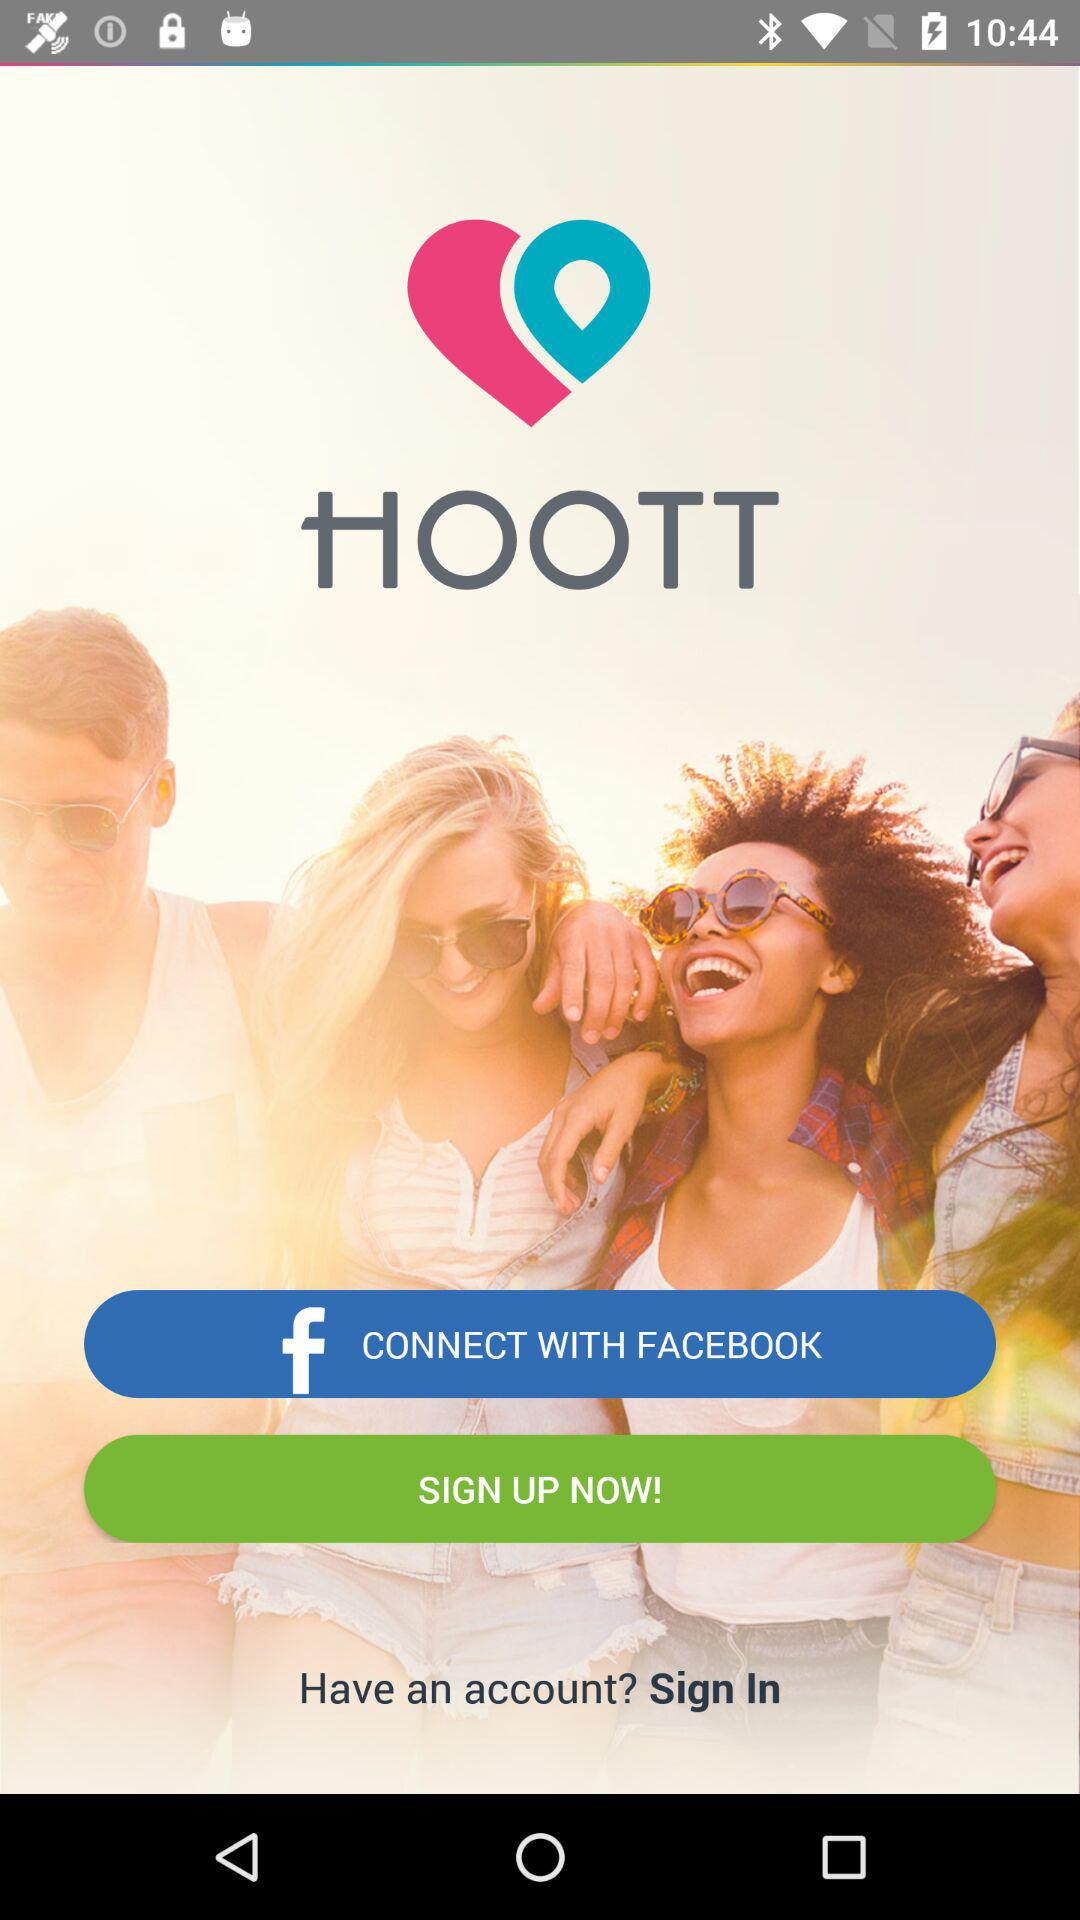Where is the user located?
When the provided information is insufficient, respond with <no answer>. <no answer> 